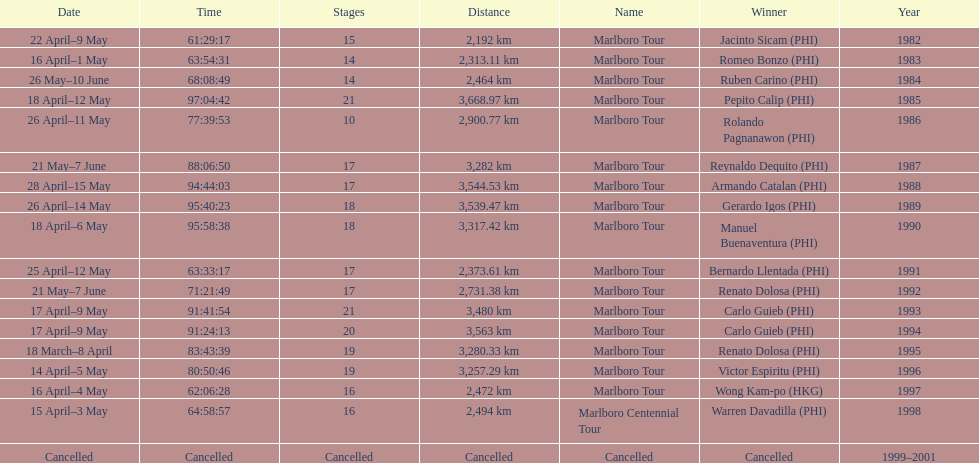How long did it take warren davadilla to complete the 1998 marlboro centennial tour? 64:58:57. 